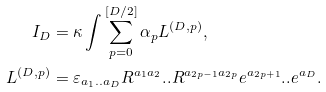Convert formula to latex. <formula><loc_0><loc_0><loc_500><loc_500>I _ { D } & = \kappa \int \sum _ { p = 0 } ^ { \left [ D / 2 \right ] } \alpha _ { p } L ^ { ( D , p ) } , \\ L ^ { ( D , p ) } & = \varepsilon _ { a _ { 1 } . . a _ { D } } R ^ { a _ { 1 } a _ { 2 } } . . R ^ { a _ { 2 p - 1 } a _ { 2 p } } e ^ { a _ { 2 p + 1 } } . . e ^ { a _ { D } } .</formula> 